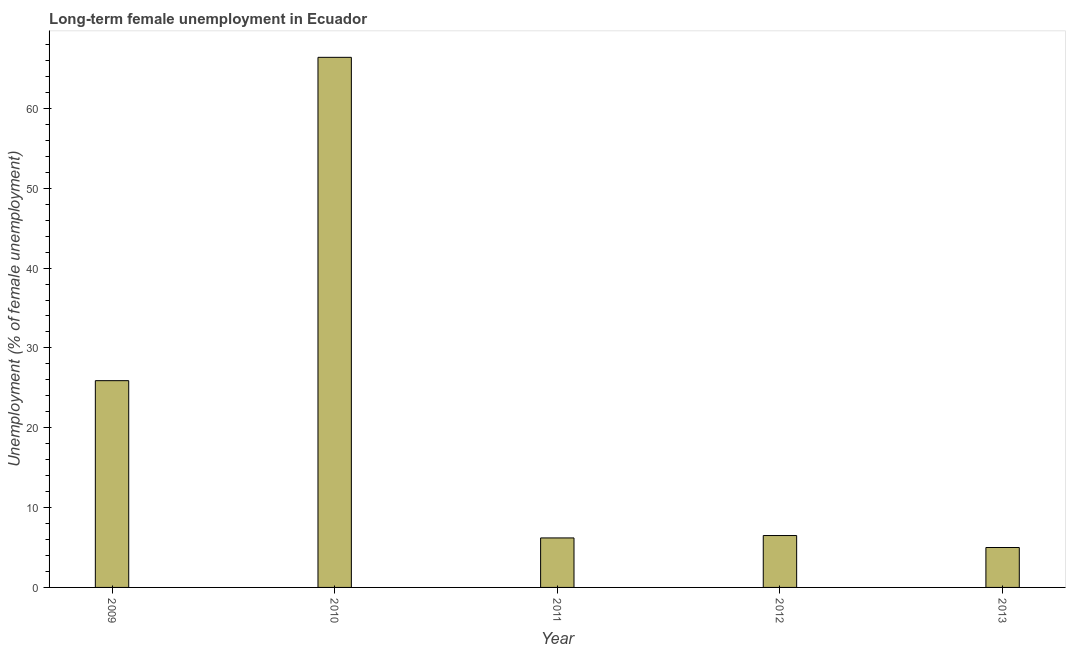Does the graph contain grids?
Your answer should be compact. No. What is the title of the graph?
Your response must be concise. Long-term female unemployment in Ecuador. What is the label or title of the X-axis?
Your response must be concise. Year. What is the label or title of the Y-axis?
Make the answer very short. Unemployment (% of female unemployment). What is the long-term female unemployment in 2011?
Provide a succinct answer. 6.2. Across all years, what is the maximum long-term female unemployment?
Offer a very short reply. 66.4. In which year was the long-term female unemployment maximum?
Keep it short and to the point. 2010. In which year was the long-term female unemployment minimum?
Offer a very short reply. 2013. What is the sum of the long-term female unemployment?
Your response must be concise. 110. What is the difference between the long-term female unemployment in 2011 and 2013?
Offer a very short reply. 1.2. What is the average long-term female unemployment per year?
Keep it short and to the point. 22. What is the median long-term female unemployment?
Offer a terse response. 6.5. In how many years, is the long-term female unemployment greater than 36 %?
Your answer should be very brief. 1. Do a majority of the years between 2011 and 2012 (inclusive) have long-term female unemployment greater than 6 %?
Offer a very short reply. Yes. What is the ratio of the long-term female unemployment in 2011 to that in 2013?
Offer a terse response. 1.24. Is the long-term female unemployment in 2012 less than that in 2013?
Your answer should be very brief. No. Is the difference between the long-term female unemployment in 2011 and 2012 greater than the difference between any two years?
Provide a short and direct response. No. What is the difference between the highest and the second highest long-term female unemployment?
Your answer should be very brief. 40.5. What is the difference between the highest and the lowest long-term female unemployment?
Your answer should be compact. 61.4. In how many years, is the long-term female unemployment greater than the average long-term female unemployment taken over all years?
Give a very brief answer. 2. How many bars are there?
Your answer should be compact. 5. What is the Unemployment (% of female unemployment) of 2009?
Provide a succinct answer. 25.9. What is the Unemployment (% of female unemployment) of 2010?
Your answer should be compact. 66.4. What is the Unemployment (% of female unemployment) of 2011?
Your answer should be compact. 6.2. What is the Unemployment (% of female unemployment) of 2013?
Keep it short and to the point. 5. What is the difference between the Unemployment (% of female unemployment) in 2009 and 2010?
Keep it short and to the point. -40.5. What is the difference between the Unemployment (% of female unemployment) in 2009 and 2013?
Your response must be concise. 20.9. What is the difference between the Unemployment (% of female unemployment) in 2010 and 2011?
Your answer should be very brief. 60.2. What is the difference between the Unemployment (% of female unemployment) in 2010 and 2012?
Ensure brevity in your answer.  59.9. What is the difference between the Unemployment (% of female unemployment) in 2010 and 2013?
Offer a terse response. 61.4. What is the ratio of the Unemployment (% of female unemployment) in 2009 to that in 2010?
Make the answer very short. 0.39. What is the ratio of the Unemployment (% of female unemployment) in 2009 to that in 2011?
Offer a very short reply. 4.18. What is the ratio of the Unemployment (% of female unemployment) in 2009 to that in 2012?
Provide a short and direct response. 3.98. What is the ratio of the Unemployment (% of female unemployment) in 2009 to that in 2013?
Offer a terse response. 5.18. What is the ratio of the Unemployment (% of female unemployment) in 2010 to that in 2011?
Your answer should be very brief. 10.71. What is the ratio of the Unemployment (% of female unemployment) in 2010 to that in 2012?
Offer a very short reply. 10.21. What is the ratio of the Unemployment (% of female unemployment) in 2010 to that in 2013?
Give a very brief answer. 13.28. What is the ratio of the Unemployment (% of female unemployment) in 2011 to that in 2012?
Provide a short and direct response. 0.95. What is the ratio of the Unemployment (% of female unemployment) in 2011 to that in 2013?
Make the answer very short. 1.24. 